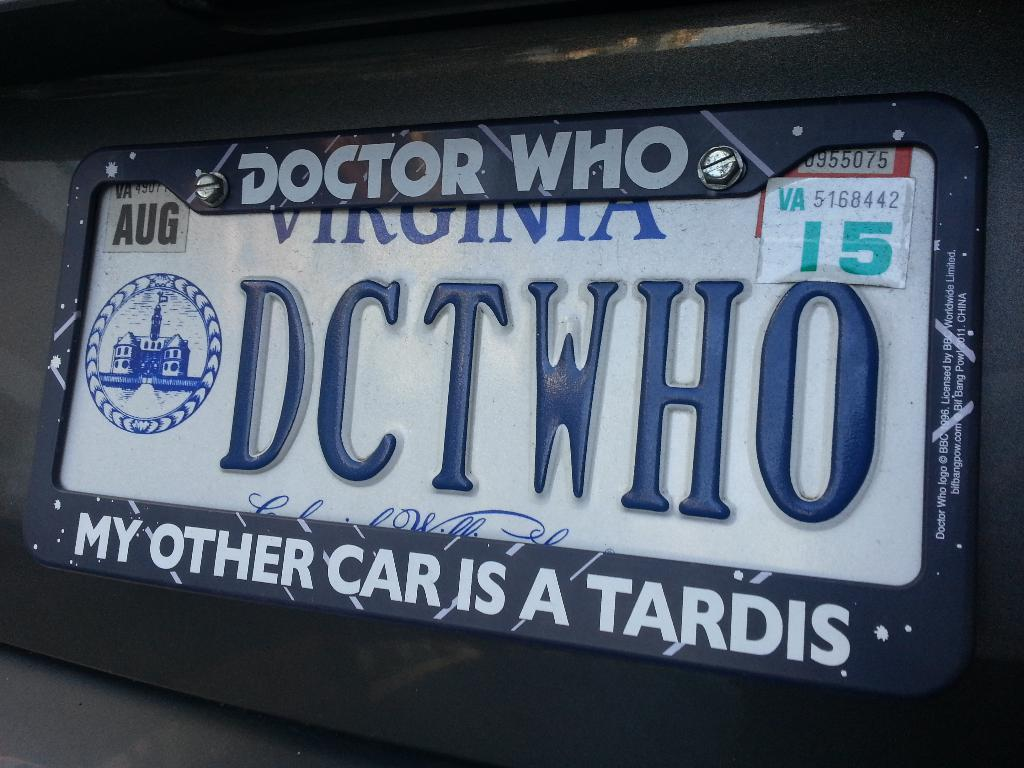<image>
Share a concise interpretation of the image provided. A car with Virginia plates has a Doctor Who cover. 